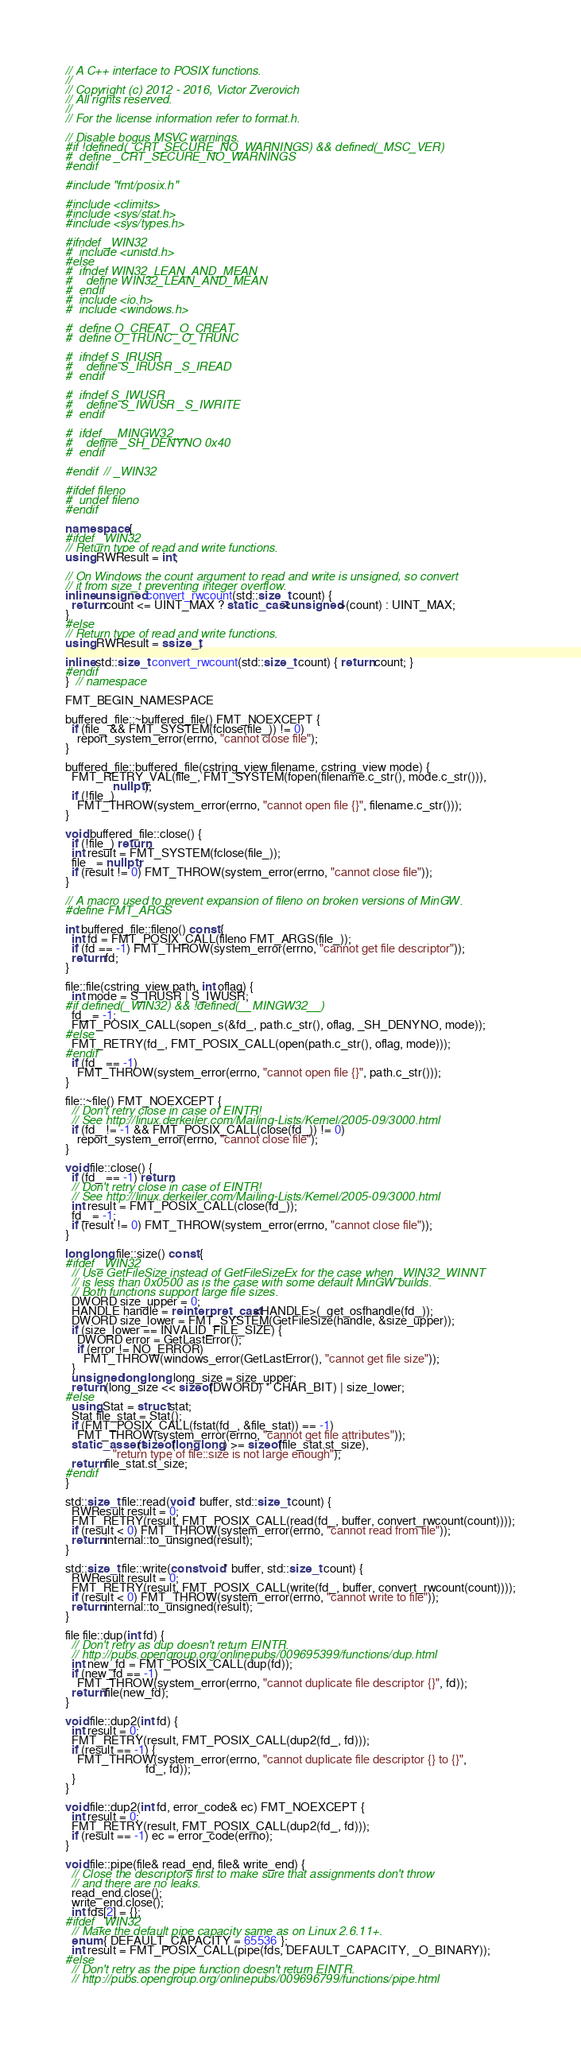Convert code to text. <code><loc_0><loc_0><loc_500><loc_500><_C++_>// A C++ interface to POSIX functions.
//
// Copyright (c) 2012 - 2016, Victor Zverovich
// All rights reserved.
//
// For the license information refer to format.h.

// Disable bogus MSVC warnings.
#if !defined(_CRT_SECURE_NO_WARNINGS) && defined(_MSC_VER)
#  define _CRT_SECURE_NO_WARNINGS
#endif

#include "fmt/posix.h"

#include <climits>
#include <sys/stat.h>
#include <sys/types.h>

#ifndef _WIN32
#  include <unistd.h>
#else
#  ifndef WIN32_LEAN_AND_MEAN
#    define WIN32_LEAN_AND_MEAN
#  endif
#  include <io.h>
#  include <windows.h>

#  define O_CREAT _O_CREAT
#  define O_TRUNC _O_TRUNC

#  ifndef S_IRUSR
#    define S_IRUSR _S_IREAD
#  endif

#  ifndef S_IWUSR
#    define S_IWUSR _S_IWRITE
#  endif

#  ifdef __MINGW32__
#    define _SH_DENYNO 0x40
#  endif

#endif  // _WIN32

#ifdef fileno
#  undef fileno
#endif

namespace {
#ifdef _WIN32
// Return type of read and write functions.
using RWResult = int;

// On Windows the count argument to read and write is unsigned, so convert
// it from size_t preventing integer overflow.
inline unsigned convert_rwcount(std::size_t count) {
  return count <= UINT_MAX ? static_cast<unsigned>(count) : UINT_MAX;
}
#else
// Return type of read and write functions.
using RWResult = ssize_t;

inline std::size_t convert_rwcount(std::size_t count) { return count; }
#endif
}  // namespace

FMT_BEGIN_NAMESPACE

buffered_file::~buffered_file() FMT_NOEXCEPT {
  if (file_ && FMT_SYSTEM(fclose(file_)) != 0)
    report_system_error(errno, "cannot close file");
}

buffered_file::buffered_file(cstring_view filename, cstring_view mode) {
  FMT_RETRY_VAL(file_, FMT_SYSTEM(fopen(filename.c_str(), mode.c_str())),
                nullptr);
  if (!file_)
    FMT_THROW(system_error(errno, "cannot open file {}", filename.c_str()));
}

void buffered_file::close() {
  if (!file_) return;
  int result = FMT_SYSTEM(fclose(file_));
  file_ = nullptr;
  if (result != 0) FMT_THROW(system_error(errno, "cannot close file"));
}

// A macro used to prevent expansion of fileno on broken versions of MinGW.
#define FMT_ARGS

int buffered_file::fileno() const {
  int fd = FMT_POSIX_CALL(fileno FMT_ARGS(file_));
  if (fd == -1) FMT_THROW(system_error(errno, "cannot get file descriptor"));
  return fd;
}

file::file(cstring_view path, int oflag) {
  int mode = S_IRUSR | S_IWUSR;
#if defined(_WIN32) && !defined(__MINGW32__)
  fd_ = -1;
  FMT_POSIX_CALL(sopen_s(&fd_, path.c_str(), oflag, _SH_DENYNO, mode));
#else
  FMT_RETRY(fd_, FMT_POSIX_CALL(open(path.c_str(), oflag, mode)));
#endif
  if (fd_ == -1)
    FMT_THROW(system_error(errno, "cannot open file {}", path.c_str()));
}

file::~file() FMT_NOEXCEPT {
  // Don't retry close in case of EINTR!
  // See http://linux.derkeiler.com/Mailing-Lists/Kernel/2005-09/3000.html
  if (fd_ != -1 && FMT_POSIX_CALL(close(fd_)) != 0)
    report_system_error(errno, "cannot close file");
}

void file::close() {
  if (fd_ == -1) return;
  // Don't retry close in case of EINTR!
  // See http://linux.derkeiler.com/Mailing-Lists/Kernel/2005-09/3000.html
  int result = FMT_POSIX_CALL(close(fd_));
  fd_ = -1;
  if (result != 0) FMT_THROW(system_error(errno, "cannot close file"));
}

long long file::size() const {
#ifdef _WIN32
  // Use GetFileSize instead of GetFileSizeEx for the case when _WIN32_WINNT
  // is less than 0x0500 as is the case with some default MinGW builds.
  // Both functions support large file sizes.
  DWORD size_upper = 0;
  HANDLE handle = reinterpret_cast<HANDLE>(_get_osfhandle(fd_));
  DWORD size_lower = FMT_SYSTEM(GetFileSize(handle, &size_upper));
  if (size_lower == INVALID_FILE_SIZE) {
    DWORD error = GetLastError();
    if (error != NO_ERROR)
      FMT_THROW(windows_error(GetLastError(), "cannot get file size"));
  }
  unsigned long long long_size = size_upper;
  return (long_size << sizeof(DWORD) * CHAR_BIT) | size_lower;
#else
  using Stat = struct stat;
  Stat file_stat = Stat();
  if (FMT_POSIX_CALL(fstat(fd_, &file_stat)) == -1)
    FMT_THROW(system_error(errno, "cannot get file attributes"));
  static_assert(sizeof(long long) >= sizeof(file_stat.st_size),
                "return type of file::size is not large enough");
  return file_stat.st_size;
#endif
}

std::size_t file::read(void* buffer, std::size_t count) {
  RWResult result = 0;
  FMT_RETRY(result, FMT_POSIX_CALL(read(fd_, buffer, convert_rwcount(count))));
  if (result < 0) FMT_THROW(system_error(errno, "cannot read from file"));
  return internal::to_unsigned(result);
}

std::size_t file::write(const void* buffer, std::size_t count) {
  RWResult result = 0;
  FMT_RETRY(result, FMT_POSIX_CALL(write(fd_, buffer, convert_rwcount(count))));
  if (result < 0) FMT_THROW(system_error(errno, "cannot write to file"));
  return internal::to_unsigned(result);
}

file file::dup(int fd) {
  // Don't retry as dup doesn't return EINTR.
  // http://pubs.opengroup.org/onlinepubs/009695399/functions/dup.html
  int new_fd = FMT_POSIX_CALL(dup(fd));
  if (new_fd == -1)
    FMT_THROW(system_error(errno, "cannot duplicate file descriptor {}", fd));
  return file(new_fd);
}

void file::dup2(int fd) {
  int result = 0;
  FMT_RETRY(result, FMT_POSIX_CALL(dup2(fd_, fd)));
  if (result == -1) {
    FMT_THROW(system_error(errno, "cannot duplicate file descriptor {} to {}",
                           fd_, fd));
  }
}

void file::dup2(int fd, error_code& ec) FMT_NOEXCEPT {
  int result = 0;
  FMT_RETRY(result, FMT_POSIX_CALL(dup2(fd_, fd)));
  if (result == -1) ec = error_code(errno);
}

void file::pipe(file& read_end, file& write_end) {
  // Close the descriptors first to make sure that assignments don't throw
  // and there are no leaks.
  read_end.close();
  write_end.close();
  int fds[2] = {};
#ifdef _WIN32
  // Make the default pipe capacity same as on Linux 2.6.11+.
  enum { DEFAULT_CAPACITY = 65536 };
  int result = FMT_POSIX_CALL(pipe(fds, DEFAULT_CAPACITY, _O_BINARY));
#else
  // Don't retry as the pipe function doesn't return EINTR.
  // http://pubs.opengroup.org/onlinepubs/009696799/functions/pipe.html</code> 